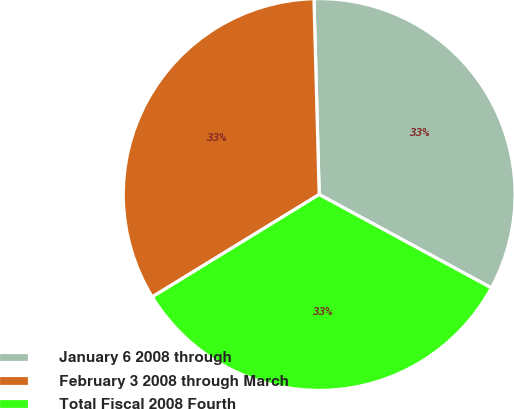Convert chart. <chart><loc_0><loc_0><loc_500><loc_500><pie_chart><fcel>January 6 2008 through<fcel>February 3 2008 through March<fcel>Total Fiscal 2008 Fourth<nl><fcel>33.33%<fcel>33.33%<fcel>33.33%<nl></chart> 